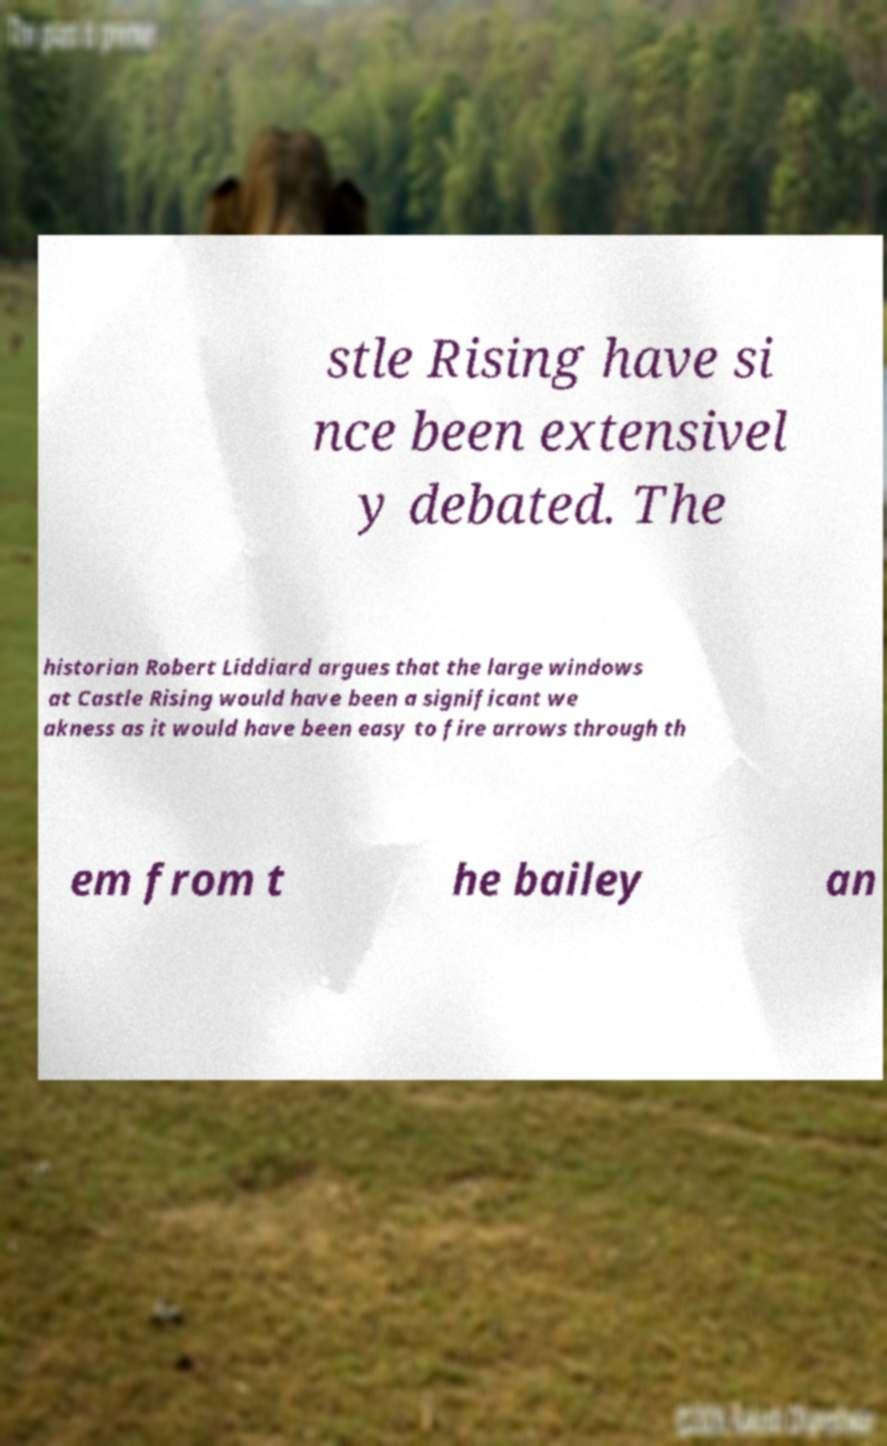For documentation purposes, I need the text within this image transcribed. Could you provide that? stle Rising have si nce been extensivel y debated. The historian Robert Liddiard argues that the large windows at Castle Rising would have been a significant we akness as it would have been easy to fire arrows through th em from t he bailey an 